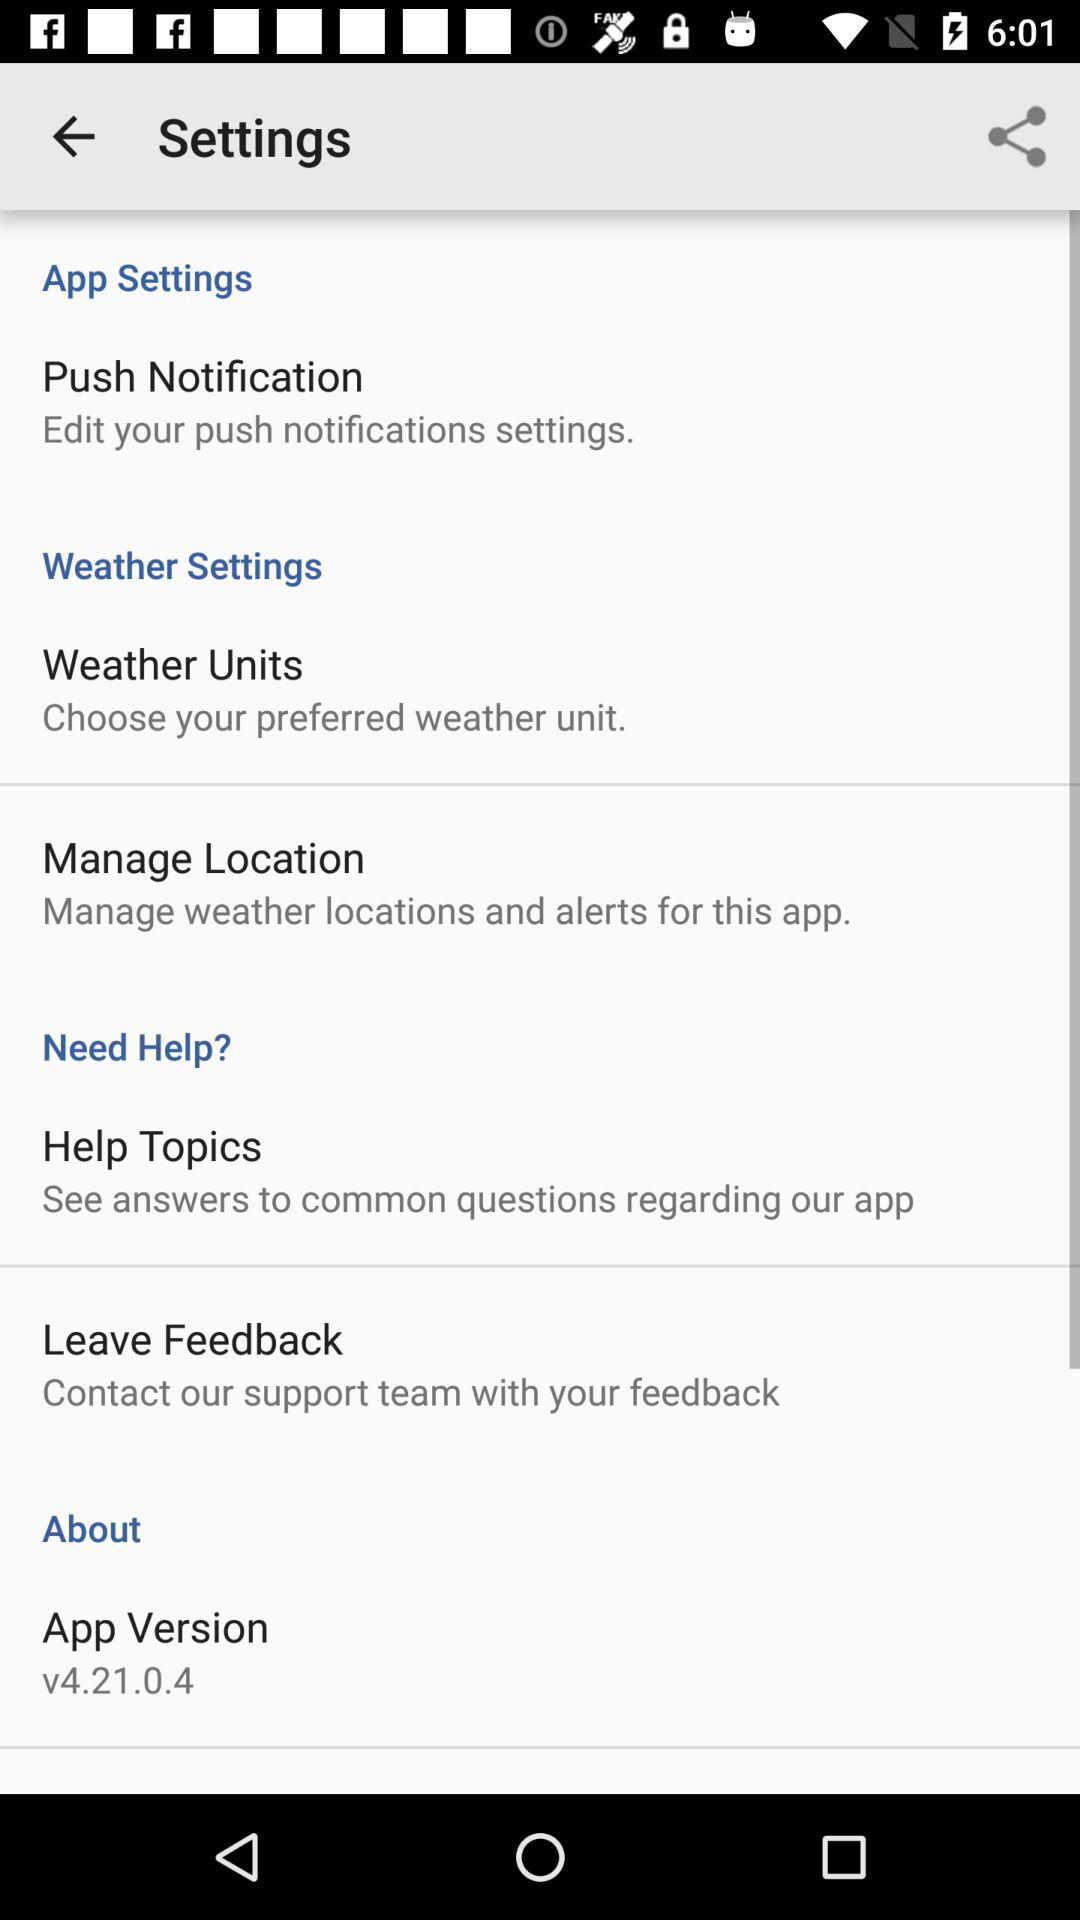What is the application version? The application version is v4.21.0.4. 